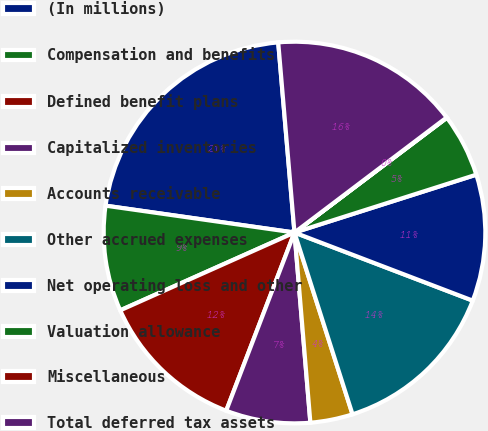Convert chart. <chart><loc_0><loc_0><loc_500><loc_500><pie_chart><fcel>(In millions)<fcel>Compensation and benefits<fcel>Defined benefit plans<fcel>Capitalized inventories<fcel>Accounts receivable<fcel>Other accrued expenses<fcel>Net operating loss and other<fcel>Valuation allowance<fcel>Miscellaneous<fcel>Total deferred tax assets<nl><fcel>21.39%<fcel>8.93%<fcel>12.49%<fcel>7.15%<fcel>3.59%<fcel>14.27%<fcel>10.71%<fcel>5.37%<fcel>0.03%<fcel>16.05%<nl></chart> 